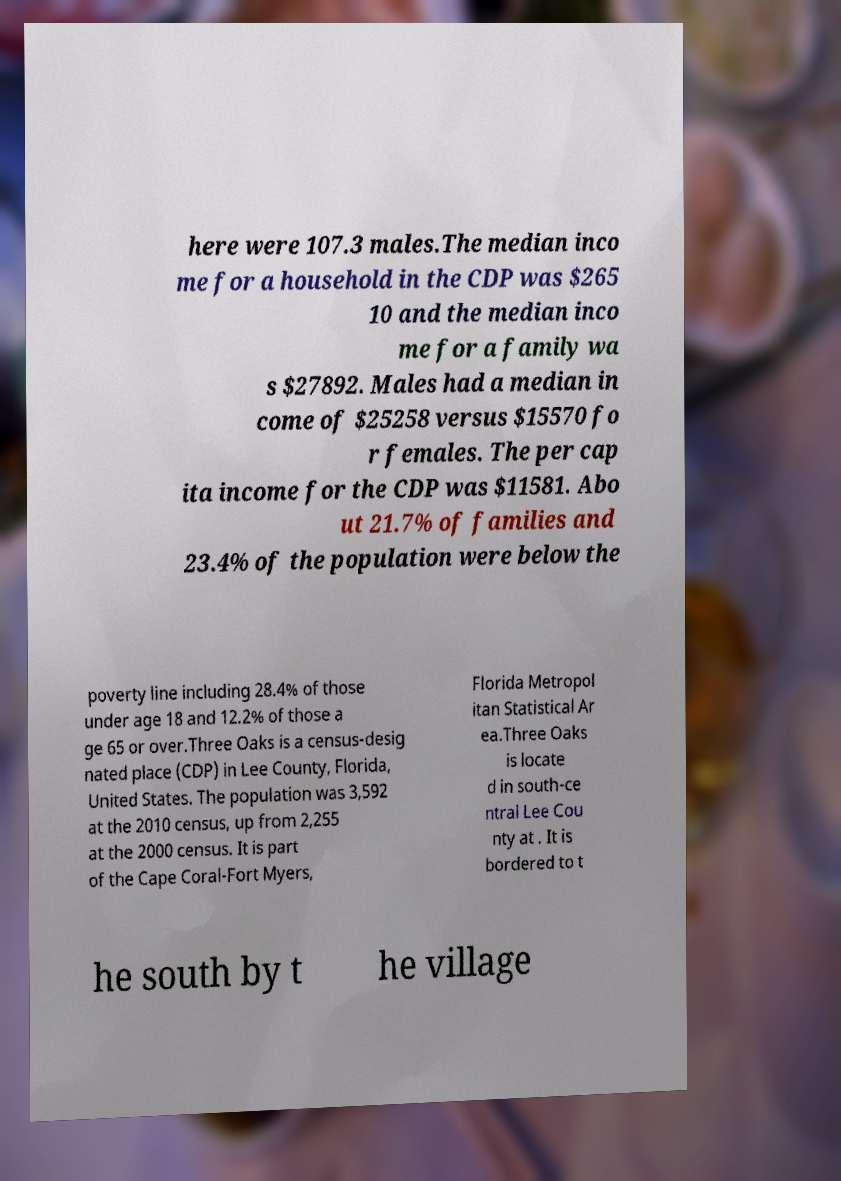For documentation purposes, I need the text within this image transcribed. Could you provide that? here were 107.3 males.The median inco me for a household in the CDP was $265 10 and the median inco me for a family wa s $27892. Males had a median in come of $25258 versus $15570 fo r females. The per cap ita income for the CDP was $11581. Abo ut 21.7% of families and 23.4% of the population were below the poverty line including 28.4% of those under age 18 and 12.2% of those a ge 65 or over.Three Oaks is a census-desig nated place (CDP) in Lee County, Florida, United States. The population was 3,592 at the 2010 census, up from 2,255 at the 2000 census. It is part of the Cape Coral-Fort Myers, Florida Metropol itan Statistical Ar ea.Three Oaks is locate d in south-ce ntral Lee Cou nty at . It is bordered to t he south by t he village 